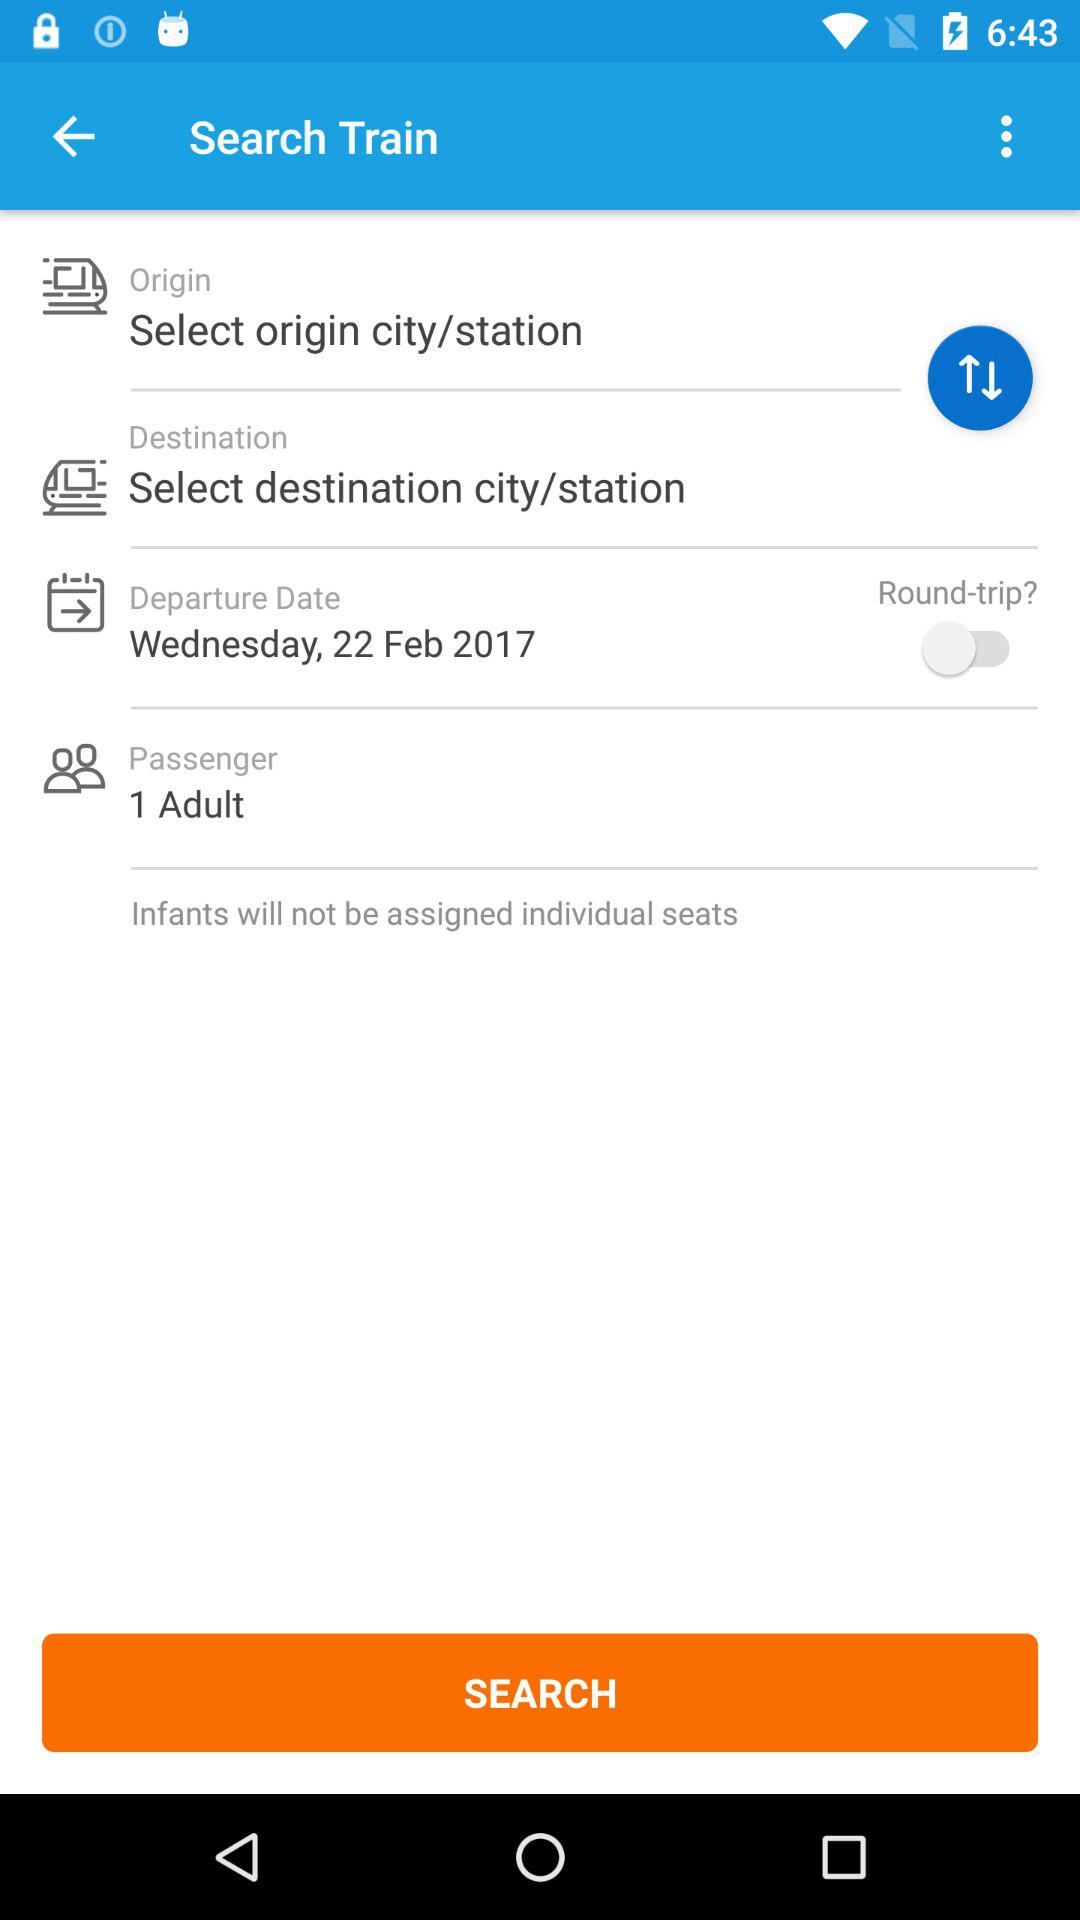How many passengers are traveling?
Answer the question using a single word or phrase. 1 